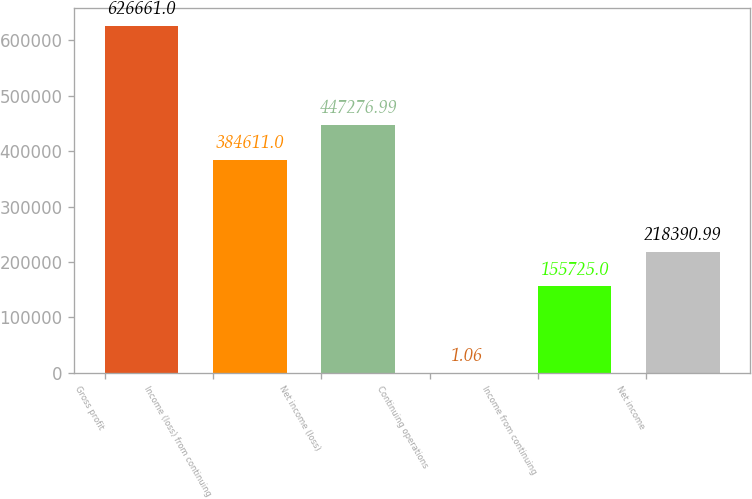Convert chart. <chart><loc_0><loc_0><loc_500><loc_500><bar_chart><fcel>Gross profit<fcel>Income (loss) from continuing<fcel>Net income (loss)<fcel>Continuing operations<fcel>Income from continuing<fcel>Net income<nl><fcel>626661<fcel>384611<fcel>447277<fcel>1.06<fcel>155725<fcel>218391<nl></chart> 